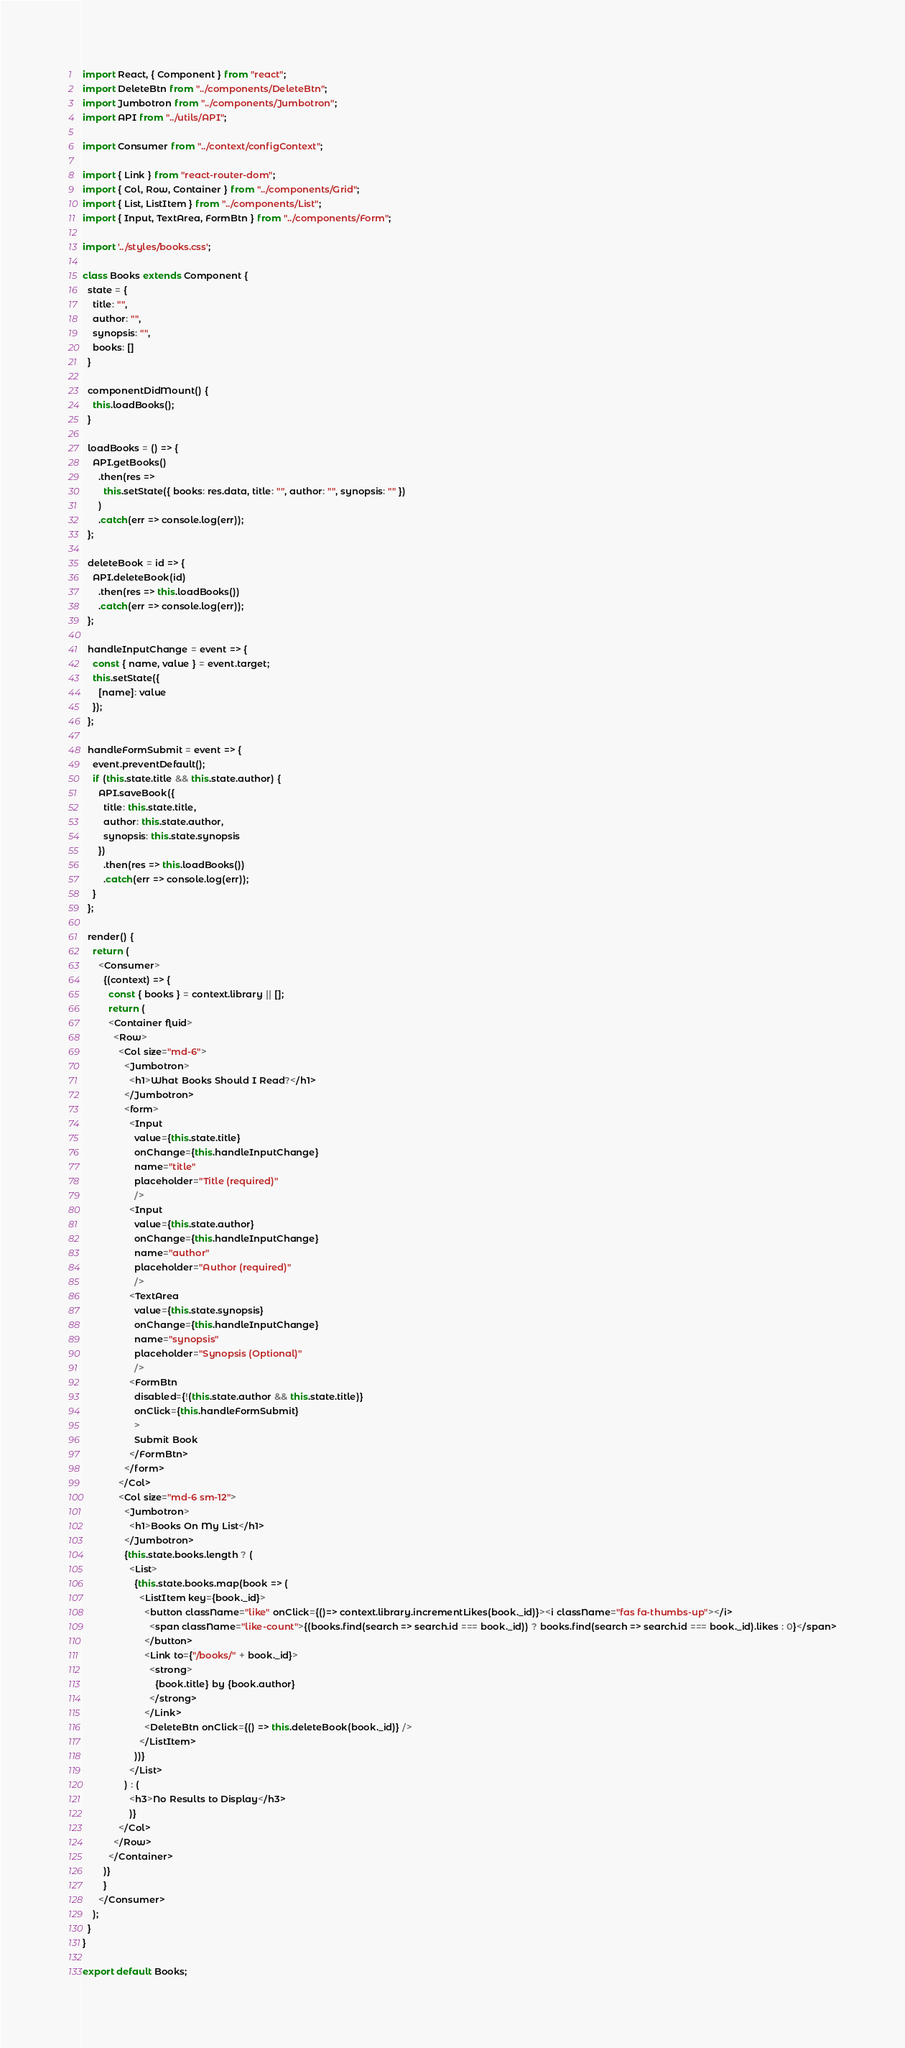<code> <loc_0><loc_0><loc_500><loc_500><_JavaScript_>import React, { Component } from "react";
import DeleteBtn from "../components/DeleteBtn";
import Jumbotron from "../components/Jumbotron";
import API from "../utils/API";

import Consumer from "../context/configContext";

import { Link } from "react-router-dom";
import { Col, Row, Container } from "../components/Grid";
import { List, ListItem } from "../components/List";
import { Input, TextArea, FormBtn } from "../components/Form";

import '../styles/books.css';

class Books extends Component {
  state = {
    title: "",
    author: "",
    synopsis: "",
    books: []
  }

  componentDidMount() {
    this.loadBooks();
  }

  loadBooks = () => {
    API.getBooks()
      .then(res =>
        this.setState({ books: res.data, title: "", author: "", synopsis: "" })
      )
      .catch(err => console.log(err));
  };

  deleteBook = id => {
    API.deleteBook(id)
      .then(res => this.loadBooks())
      .catch(err => console.log(err));
  };

  handleInputChange = event => {
    const { name, value } = event.target;
    this.setState({
      [name]: value
    });
  };

  handleFormSubmit = event => {
    event.preventDefault();
    if (this.state.title && this.state.author) {
      API.saveBook({
        title: this.state.title,
        author: this.state.author,
        synopsis: this.state.synopsis
      })
        .then(res => this.loadBooks())
        .catch(err => console.log(err));
    }
  };

  render() {
    return (
      <Consumer>
        {(context) => {
          const { books } = context.library || [];
          return (
          <Container fluid>
            <Row>
              <Col size="md-6">
                <Jumbotron>
                  <h1>What Books Should I Read?</h1>
                </Jumbotron>
                <form>
                  <Input
                    value={this.state.title}
                    onChange={this.handleInputChange}
                    name="title"
                    placeholder="Title (required)"
                    />
                  <Input
                    value={this.state.author}
                    onChange={this.handleInputChange}
                    name="author"
                    placeholder="Author (required)"
                    />
                  <TextArea
                    value={this.state.synopsis}
                    onChange={this.handleInputChange}
                    name="synopsis"
                    placeholder="Synopsis (Optional)"
                    />
                  <FormBtn
                    disabled={!(this.state.author && this.state.title)}
                    onClick={this.handleFormSubmit}
                    >
                    Submit Book
                  </FormBtn>
                </form>
              </Col>
              <Col size="md-6 sm-12">
                <Jumbotron>
                  <h1>Books On My List</h1>
                </Jumbotron>
                {this.state.books.length ? (
                  <List>
                    {this.state.books.map(book => (
                      <ListItem key={book._id}>
                        <button className="like" onClick={()=> context.library.incrementLikes(book._id)}><i className="fas fa-thumbs-up"></i>
                          <span className="like-count">{(books.find(search => search.id === book._id)) ? books.find(search => search.id === book._id).likes : 0}</span>
                        </button>
                        <Link to={"/books/" + book._id}>
                          <strong>
                            {book.title} by {book.author}
                          </strong>
                        </Link>
                        <DeleteBtn onClick={() => this.deleteBook(book._id)} />
                      </ListItem>
                    ))}
                  </List>
                ) : (
                  <h3>No Results to Display</h3>
                  )}
              </Col>
            </Row>
          </Container>
        )}
        }
      </Consumer>
    );
  }
}

export default Books;
</code> 